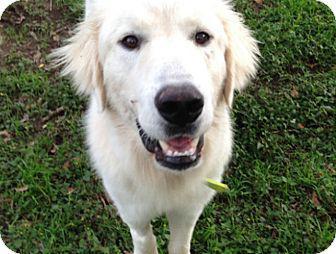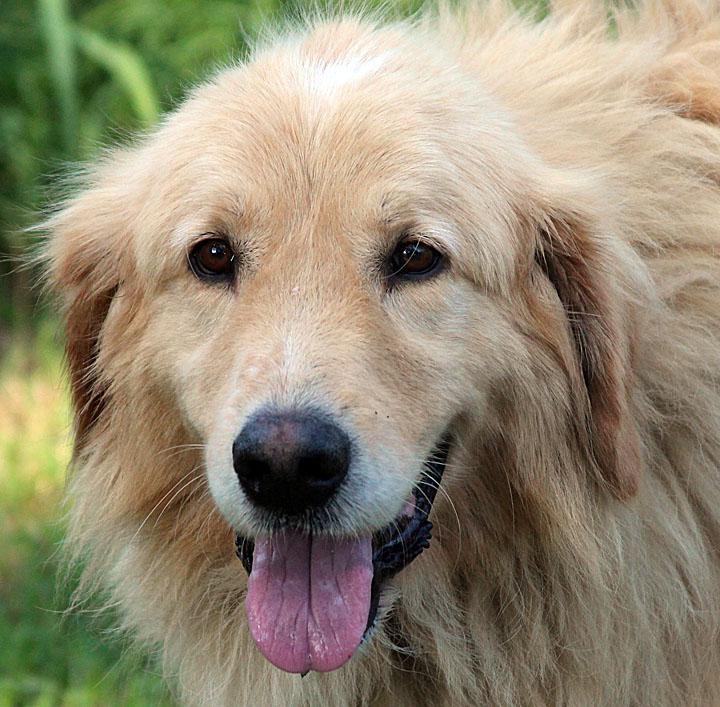The first image is the image on the left, the second image is the image on the right. Evaluate the accuracy of this statement regarding the images: "In at least one of the images, the dog is inside.". Is it true? Answer yes or no. No. 